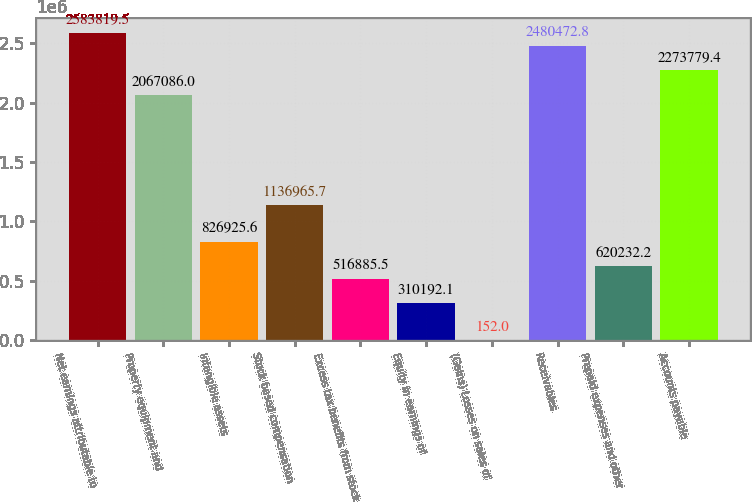<chart> <loc_0><loc_0><loc_500><loc_500><bar_chart><fcel>Net earnings attributable to<fcel>Property equipment and<fcel>Intangible assets<fcel>Stock based compensation<fcel>Excess tax benefits from stock<fcel>Equity in earnings of<fcel>(Gains) Losses on sales of<fcel>Receivables<fcel>Prepaid expenses and other<fcel>Accounts payable<nl><fcel>2.58382e+06<fcel>2.06709e+06<fcel>826926<fcel>1.13697e+06<fcel>516886<fcel>310192<fcel>152<fcel>2.48047e+06<fcel>620232<fcel>2.27378e+06<nl></chart> 